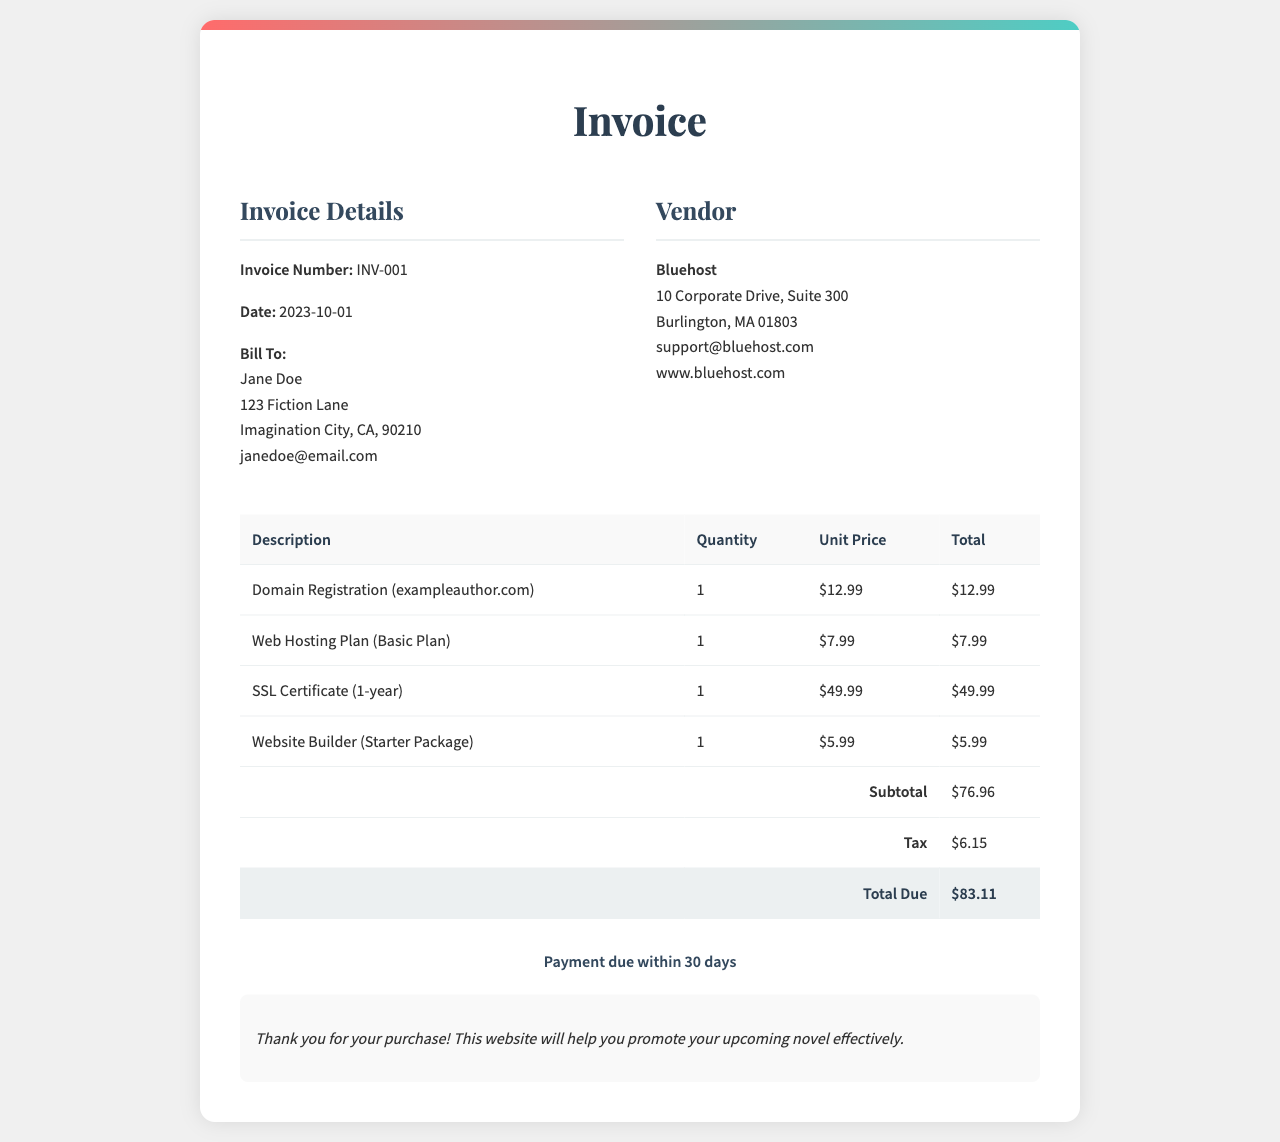What is the invoice number? The invoice number is clearly stated in the document under the invoice details section, labeled as "Invoice Number: INV-001".
Answer: INV-001 What is the date of the invoice? The date is also mentioned in the invoice details section, shown as "Date: 2023-10-01".
Answer: 2023-10-01 Who is the invoice billed to? The "Bill To" section lists the name and address of the customer receiving the invoice, which is "Jane Doe".
Answer: Jane Doe What is the total amount due? The total due is calculated and presented at the end of the invoice, labeled as "Total Due: $83.11".
Answer: $83.11 What services are included in the invoice? The document lists various services such as domain registration, web hosting, SSL certificate, and website builder, all pertaining to the invoice.
Answer: Domain Registration, Web Hosting Plan, SSL Certificate, Website Builder What is the payment term stated in the document? The payment terms are found in the payment terms section, indicating that payment is due "within 30 days".
Answer: within 30 days What is the subtotal before tax? The subtotal is provided in the invoice, summarized as "Subtotal: $76.96".
Answer: $76.96 Which vendor provided the services? The vendor section identifies the company, which is "Bluehost".
Answer: Bluehost What is the tax amount calculated in the invoice? The tax amount is mentioned in the invoice under the tax section as "Tax: $6.15".
Answer: $6.15 What does the invoice thank the customer for? A note at the end of the invoice expresses gratitude for the customer's purchase, mentioning "Thank you for your purchase!"
Answer: your purchase 